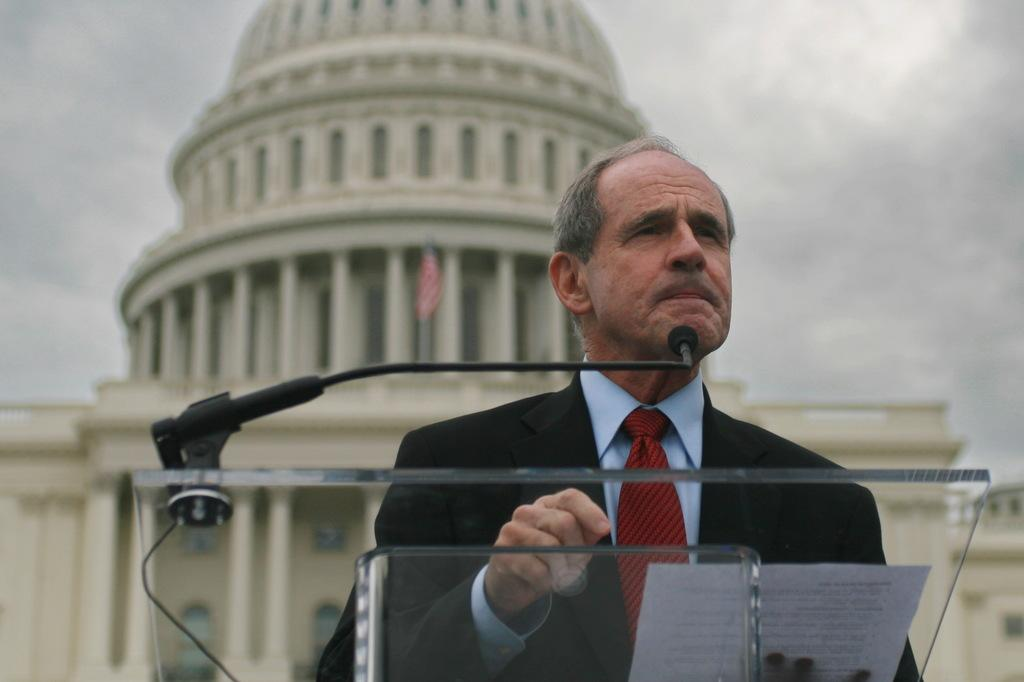Who is present in the image? There is a man in the image. What is the man wearing? The man is wearing a black jacket. What is the man holding in the image? The man is holding a paper. What can be seen in the background of the image? There is a building, a flag, and the sky visible in the background of the image. What type of gold furniture can be seen in the image? There is no gold furniture present in the image. What is the plot of the story being told in the image? The image does not depict a story or plot; it is a photograph of a man holding a paper with a background of a building, flag, and sky. 